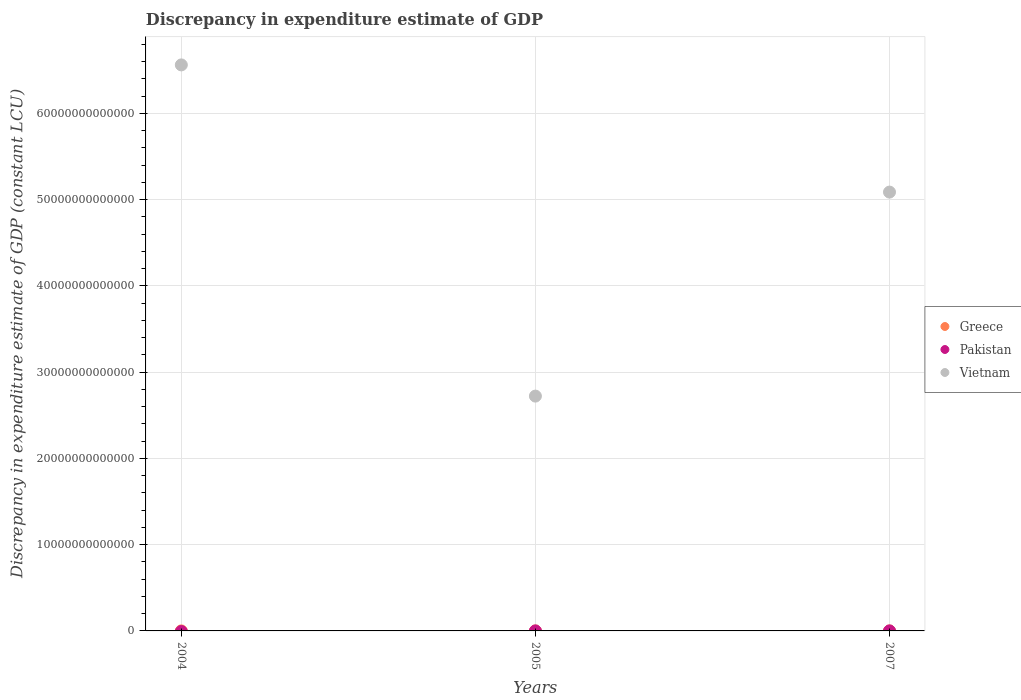What is the discrepancy in expenditure estimate of GDP in Pakistan in 2005?
Offer a very short reply. 0. Across all years, what is the maximum discrepancy in expenditure estimate of GDP in Vietnam?
Provide a short and direct response. 6.56e+13. Across all years, what is the minimum discrepancy in expenditure estimate of GDP in Greece?
Give a very brief answer. 4.25e+08. What is the total discrepancy in expenditure estimate of GDP in Vietnam in the graph?
Your response must be concise. 1.44e+14. What is the difference between the discrepancy in expenditure estimate of GDP in Greece in 2004 and that in 2007?
Keep it short and to the point. -2.47e+08. What is the difference between the discrepancy in expenditure estimate of GDP in Greece in 2004 and the discrepancy in expenditure estimate of GDP in Pakistan in 2005?
Your answer should be very brief. 9.29e+08. What is the average discrepancy in expenditure estimate of GDP in Vietnam per year?
Your answer should be very brief. 4.79e+13. In the year 2005, what is the difference between the discrepancy in expenditure estimate of GDP in Greece and discrepancy in expenditure estimate of GDP in Vietnam?
Ensure brevity in your answer.  -2.72e+13. What is the ratio of the discrepancy in expenditure estimate of GDP in Vietnam in 2004 to that in 2005?
Your response must be concise. 2.41. Is the discrepancy in expenditure estimate of GDP in Greece in 2005 less than that in 2007?
Your answer should be very brief. Yes. Is the difference between the discrepancy in expenditure estimate of GDP in Greece in 2004 and 2007 greater than the difference between the discrepancy in expenditure estimate of GDP in Vietnam in 2004 and 2007?
Ensure brevity in your answer.  No. What is the difference between the highest and the second highest discrepancy in expenditure estimate of GDP in Greece?
Your answer should be very brief. 2.47e+08. What is the difference between the highest and the lowest discrepancy in expenditure estimate of GDP in Greece?
Offer a terse response. 7.52e+08. Is it the case that in every year, the sum of the discrepancy in expenditure estimate of GDP in Greece and discrepancy in expenditure estimate of GDP in Pakistan  is greater than the discrepancy in expenditure estimate of GDP in Vietnam?
Provide a short and direct response. No. Does the discrepancy in expenditure estimate of GDP in Greece monotonically increase over the years?
Provide a succinct answer. No. How many dotlines are there?
Your answer should be very brief. 2. How many years are there in the graph?
Your answer should be compact. 3. What is the difference between two consecutive major ticks on the Y-axis?
Your response must be concise. 1.00e+13. Are the values on the major ticks of Y-axis written in scientific E-notation?
Your answer should be very brief. No. Does the graph contain any zero values?
Ensure brevity in your answer.  Yes. Does the graph contain grids?
Your response must be concise. Yes. Where does the legend appear in the graph?
Offer a very short reply. Center right. How are the legend labels stacked?
Offer a terse response. Vertical. What is the title of the graph?
Provide a succinct answer. Discrepancy in expenditure estimate of GDP. What is the label or title of the X-axis?
Give a very brief answer. Years. What is the label or title of the Y-axis?
Offer a very short reply. Discrepancy in expenditure estimate of GDP (constant LCU). What is the Discrepancy in expenditure estimate of GDP (constant LCU) of Greece in 2004?
Give a very brief answer. 9.29e+08. What is the Discrepancy in expenditure estimate of GDP (constant LCU) of Vietnam in 2004?
Your response must be concise. 6.56e+13. What is the Discrepancy in expenditure estimate of GDP (constant LCU) of Greece in 2005?
Your answer should be very brief. 4.25e+08. What is the Discrepancy in expenditure estimate of GDP (constant LCU) in Pakistan in 2005?
Provide a short and direct response. 0. What is the Discrepancy in expenditure estimate of GDP (constant LCU) in Vietnam in 2005?
Your answer should be very brief. 2.72e+13. What is the Discrepancy in expenditure estimate of GDP (constant LCU) of Greece in 2007?
Make the answer very short. 1.18e+09. What is the Discrepancy in expenditure estimate of GDP (constant LCU) in Pakistan in 2007?
Make the answer very short. 0. What is the Discrepancy in expenditure estimate of GDP (constant LCU) in Vietnam in 2007?
Offer a very short reply. 5.09e+13. Across all years, what is the maximum Discrepancy in expenditure estimate of GDP (constant LCU) in Greece?
Give a very brief answer. 1.18e+09. Across all years, what is the maximum Discrepancy in expenditure estimate of GDP (constant LCU) in Vietnam?
Offer a terse response. 6.56e+13. Across all years, what is the minimum Discrepancy in expenditure estimate of GDP (constant LCU) in Greece?
Your answer should be very brief. 4.25e+08. Across all years, what is the minimum Discrepancy in expenditure estimate of GDP (constant LCU) of Vietnam?
Give a very brief answer. 2.72e+13. What is the total Discrepancy in expenditure estimate of GDP (constant LCU) of Greece in the graph?
Your answer should be very brief. 2.53e+09. What is the total Discrepancy in expenditure estimate of GDP (constant LCU) of Pakistan in the graph?
Provide a short and direct response. 0. What is the total Discrepancy in expenditure estimate of GDP (constant LCU) in Vietnam in the graph?
Give a very brief answer. 1.44e+14. What is the difference between the Discrepancy in expenditure estimate of GDP (constant LCU) of Greece in 2004 and that in 2005?
Give a very brief answer. 5.04e+08. What is the difference between the Discrepancy in expenditure estimate of GDP (constant LCU) of Vietnam in 2004 and that in 2005?
Your answer should be compact. 3.84e+13. What is the difference between the Discrepancy in expenditure estimate of GDP (constant LCU) of Greece in 2004 and that in 2007?
Your answer should be very brief. -2.47e+08. What is the difference between the Discrepancy in expenditure estimate of GDP (constant LCU) of Vietnam in 2004 and that in 2007?
Offer a terse response. 1.47e+13. What is the difference between the Discrepancy in expenditure estimate of GDP (constant LCU) of Greece in 2005 and that in 2007?
Make the answer very short. -7.52e+08. What is the difference between the Discrepancy in expenditure estimate of GDP (constant LCU) of Vietnam in 2005 and that in 2007?
Your response must be concise. -2.37e+13. What is the difference between the Discrepancy in expenditure estimate of GDP (constant LCU) of Greece in 2004 and the Discrepancy in expenditure estimate of GDP (constant LCU) of Vietnam in 2005?
Offer a very short reply. -2.72e+13. What is the difference between the Discrepancy in expenditure estimate of GDP (constant LCU) of Greece in 2004 and the Discrepancy in expenditure estimate of GDP (constant LCU) of Vietnam in 2007?
Provide a succinct answer. -5.09e+13. What is the difference between the Discrepancy in expenditure estimate of GDP (constant LCU) of Greece in 2005 and the Discrepancy in expenditure estimate of GDP (constant LCU) of Vietnam in 2007?
Give a very brief answer. -5.09e+13. What is the average Discrepancy in expenditure estimate of GDP (constant LCU) in Greece per year?
Provide a succinct answer. 8.43e+08. What is the average Discrepancy in expenditure estimate of GDP (constant LCU) in Vietnam per year?
Offer a very short reply. 4.79e+13. In the year 2004, what is the difference between the Discrepancy in expenditure estimate of GDP (constant LCU) in Greece and Discrepancy in expenditure estimate of GDP (constant LCU) in Vietnam?
Your response must be concise. -6.56e+13. In the year 2005, what is the difference between the Discrepancy in expenditure estimate of GDP (constant LCU) in Greece and Discrepancy in expenditure estimate of GDP (constant LCU) in Vietnam?
Provide a succinct answer. -2.72e+13. In the year 2007, what is the difference between the Discrepancy in expenditure estimate of GDP (constant LCU) in Greece and Discrepancy in expenditure estimate of GDP (constant LCU) in Vietnam?
Give a very brief answer. -5.09e+13. What is the ratio of the Discrepancy in expenditure estimate of GDP (constant LCU) of Greece in 2004 to that in 2005?
Keep it short and to the point. 2.19. What is the ratio of the Discrepancy in expenditure estimate of GDP (constant LCU) of Vietnam in 2004 to that in 2005?
Offer a terse response. 2.41. What is the ratio of the Discrepancy in expenditure estimate of GDP (constant LCU) of Greece in 2004 to that in 2007?
Keep it short and to the point. 0.79. What is the ratio of the Discrepancy in expenditure estimate of GDP (constant LCU) in Vietnam in 2004 to that in 2007?
Make the answer very short. 1.29. What is the ratio of the Discrepancy in expenditure estimate of GDP (constant LCU) in Greece in 2005 to that in 2007?
Give a very brief answer. 0.36. What is the ratio of the Discrepancy in expenditure estimate of GDP (constant LCU) of Vietnam in 2005 to that in 2007?
Your answer should be very brief. 0.54. What is the difference between the highest and the second highest Discrepancy in expenditure estimate of GDP (constant LCU) of Greece?
Offer a very short reply. 2.47e+08. What is the difference between the highest and the second highest Discrepancy in expenditure estimate of GDP (constant LCU) in Vietnam?
Your answer should be very brief. 1.47e+13. What is the difference between the highest and the lowest Discrepancy in expenditure estimate of GDP (constant LCU) in Greece?
Provide a short and direct response. 7.52e+08. What is the difference between the highest and the lowest Discrepancy in expenditure estimate of GDP (constant LCU) of Vietnam?
Make the answer very short. 3.84e+13. 